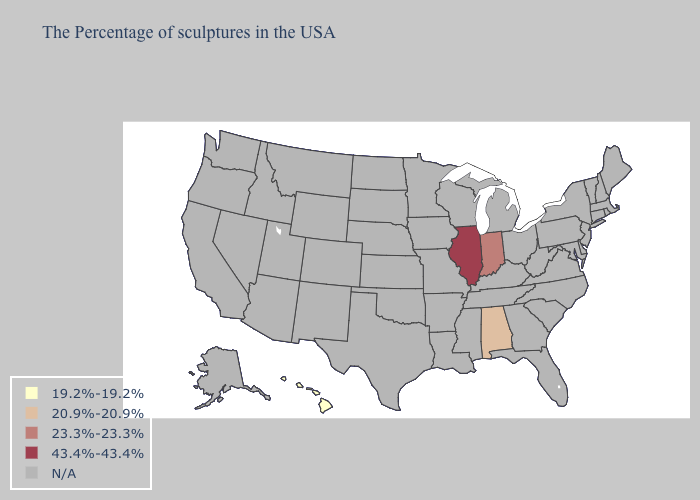Does Illinois have the highest value in the USA?
Keep it brief. Yes. What is the highest value in states that border Michigan?
Keep it brief. 23.3%-23.3%. How many symbols are there in the legend?
Quick response, please. 5. Name the states that have a value in the range 23.3%-23.3%?
Keep it brief. Indiana. What is the highest value in the USA?
Quick response, please. 43.4%-43.4%. Does Illinois have the lowest value in the USA?
Quick response, please. No. Name the states that have a value in the range 19.2%-19.2%?
Concise answer only. Hawaii. What is the value of Michigan?
Keep it brief. N/A. 